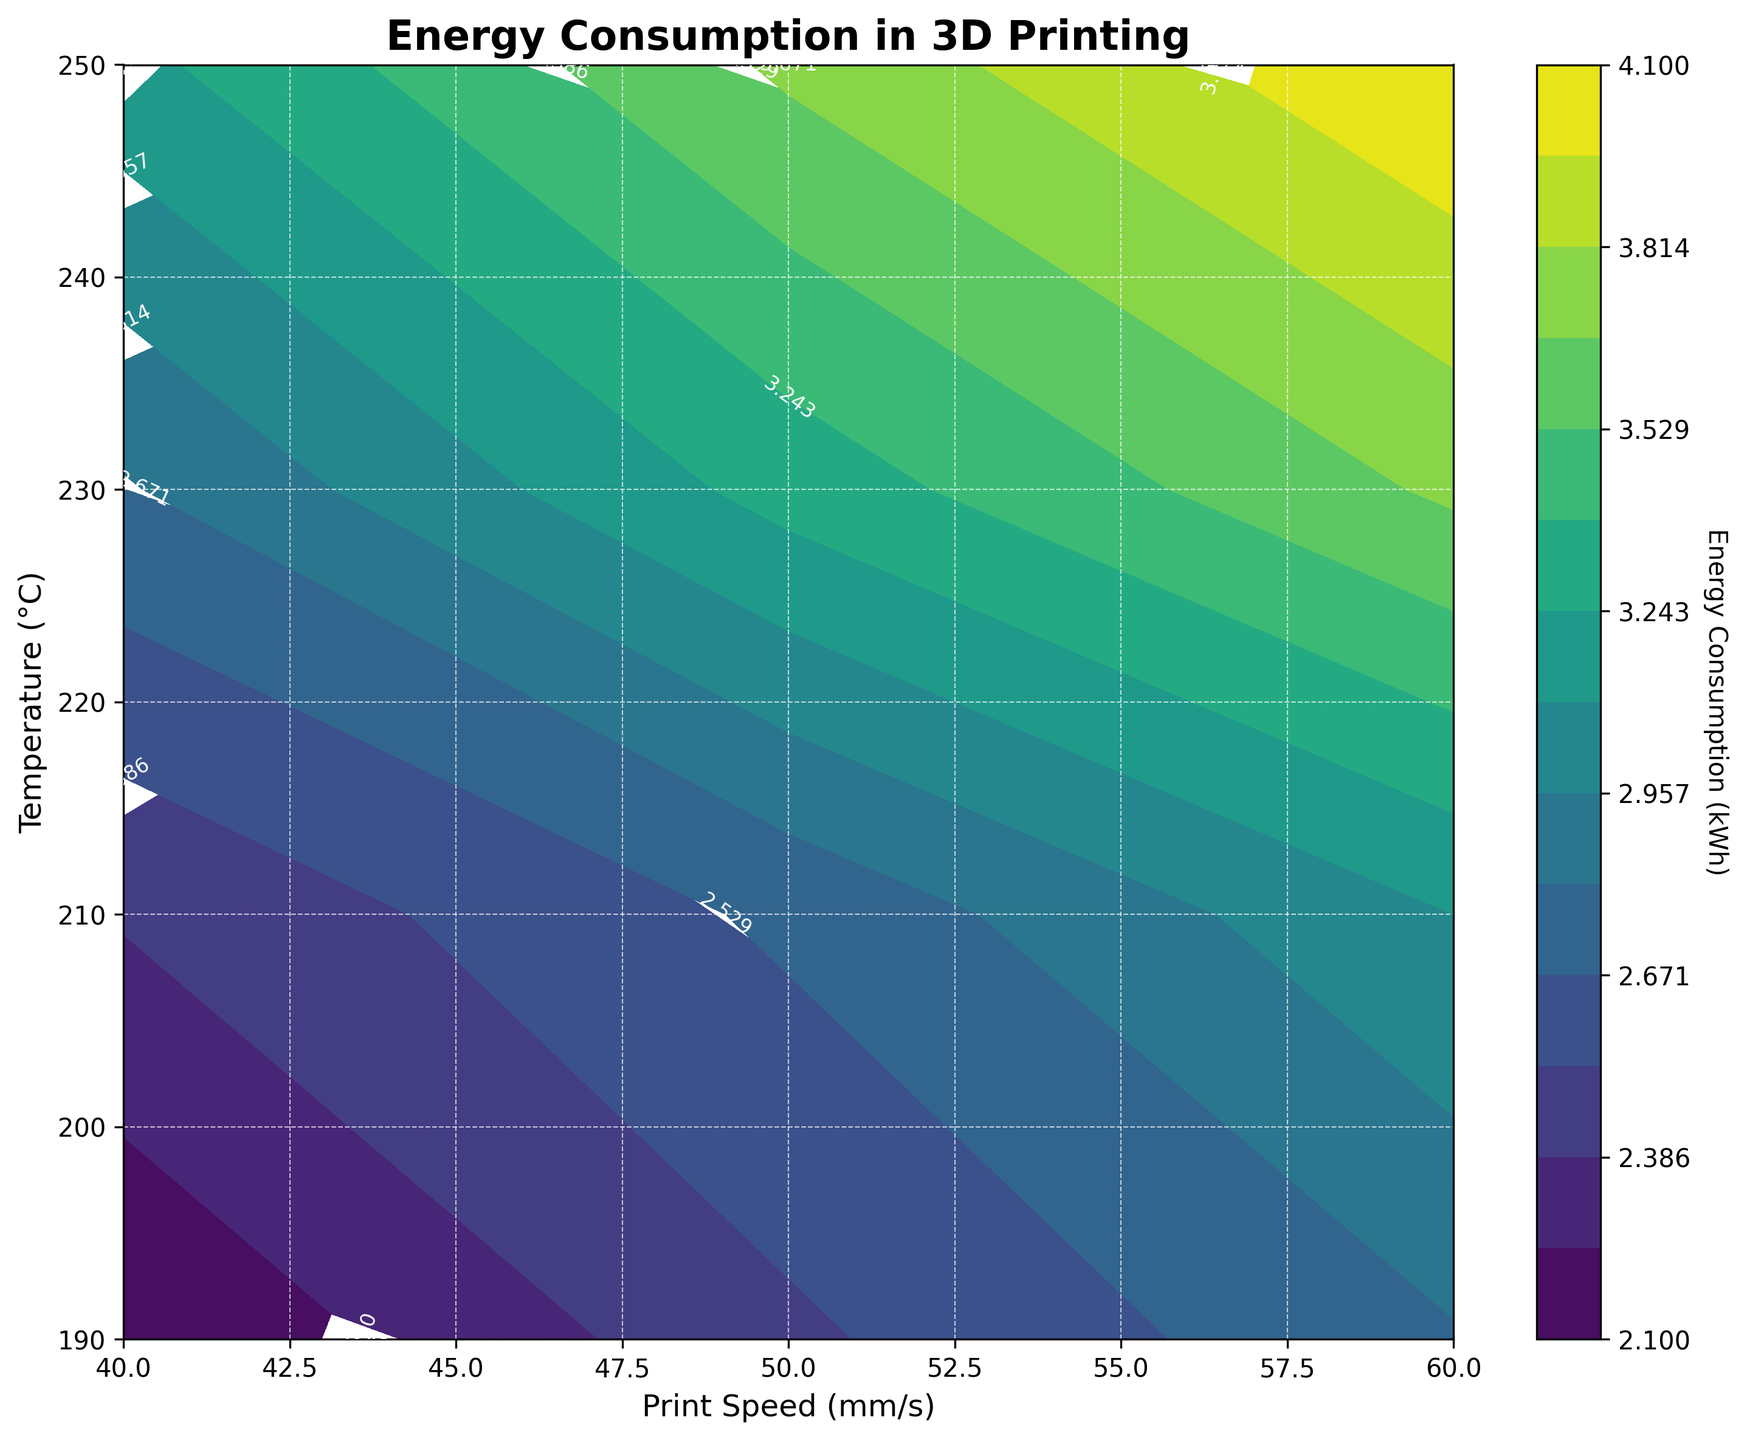What is the title of the contour plot? Reading the top of the contour plot, the title is clearly labeled as "Energy Consumption in 3D Printing".
Answer: Energy Consumption in 3D Printing What are the labels of the x-axis and y-axis? The x-axis label is displayed as "Print Speed (mm/s)", and the y-axis label is shown as "Temperature (°C)".
Answer: Print Speed (mm/s), Temperature (°C) What is the range of Energy Consumption (kWh) shown in the colorbar? Observing the colorbar on the right side of the contour plot, it ranges from the minimum value to the maximum value, covering 2.1 kWh to 4.1 kWh.
Answer: 2.1 kWh to 4.1 kWh How does Energy Consumption change as Print Speed increases from 40 mm/s to 60 mm/s at a constant temperature of 230°C? At 230°C, following the contour from 40 mm/s to 60 mm/s, the energy consumption increases from 2.8 kWh to 3.7 kWh.
Answer: Increases from 2.8 kWh to 3.7 kWh Which combination of Print Speed and Temperature results in the highest Energy Consumption? By locating the darkest area on the contour plot, the highest energy consumption is at 250°C and 60 mm/s, marked by the contour indicating 4.1 kWh.
Answer: 250°C and 60 mm/s At which temperature does the Print Speed have the least impact on Energy Consumption? Comparing contour levels horizontally, the values are most consistent at 190°C, indicating that print speed change from 40 mm/s to 60 mm/s shows the least variation in energy consumption (2.1 kWh to 2.8 kWh).
Answer: 190°C If you want to minimize Energy Consumption, what combination of operational parameters should you use? To find the lowest energy consumption in the contour plot, the point with the lightest color is at 190°C and 40 mm/s, where the energy consumption is 2.1 kWh.
Answer: 190°C and 40 mm/s What is the average Energy Consumption at 210°C across all print speeds? The energy consumption values at 210°C are 2.4, 2.7, and 3.1 kWh. The average is calculated as (2.4 + 2.7 + 3.1)/3 = 2.73 kWh.
Answer: 2.73 kWh 